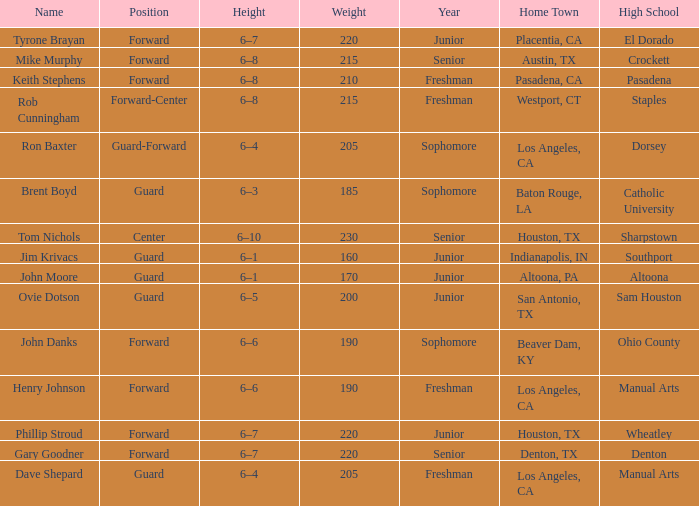What is the Name with a Year of junior, and a High School with wheatley? Phillip Stroud. 